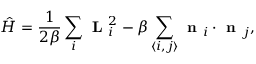<formula> <loc_0><loc_0><loc_500><loc_500>\hat { H } = \frac { 1 } { 2 \beta } \sum _ { i } L _ { i } ^ { 2 } - \beta \sum _ { \langle i , j \rangle } n _ { i } \cdot n _ { j } ,</formula> 